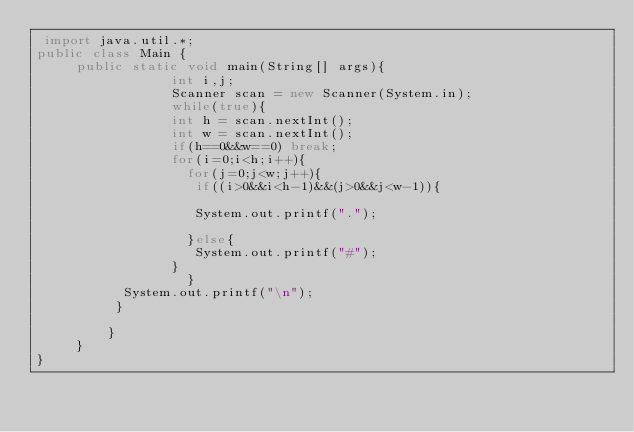Convert code to text. <code><loc_0><loc_0><loc_500><loc_500><_Java_> import java.util.*;
public class Main {
	 public static void main(String[] args){
		         int i,j;
		         Scanner scan = new Scanner(System.in);
		         while(true){
		         int h = scan.nextInt();
		         int w = scan.nextInt();
		         if(h==0&&w==0) break;
		         for(i=0;i<h;i++){
		           for(j=0;j<w;j++){
		        	if((i>0&&i<h-1)&&(j>0&&j<w-1)){
		        		
		            System.out.printf(".");
		        		
		           }else{
		            System.out.printf("#");
		         }
		           }
		   System.out.printf("\n");
		  }
		           
		 }
	 }
}
	    </code> 